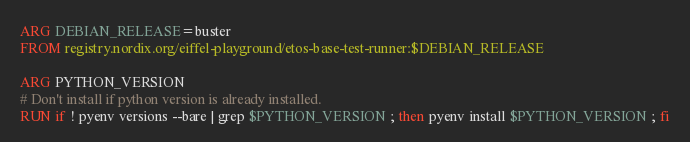Convert code to text. <code><loc_0><loc_0><loc_500><loc_500><_Dockerfile_>ARG DEBIAN_RELEASE=buster
FROM registry.nordix.org/eiffel-playground/etos-base-test-runner:$DEBIAN_RELEASE

ARG PYTHON_VERSION
# Don't install if python version is already installed.
RUN if ! pyenv versions --bare | grep $PYTHON_VERSION ; then pyenv install $PYTHON_VERSION ; fi
</code> 